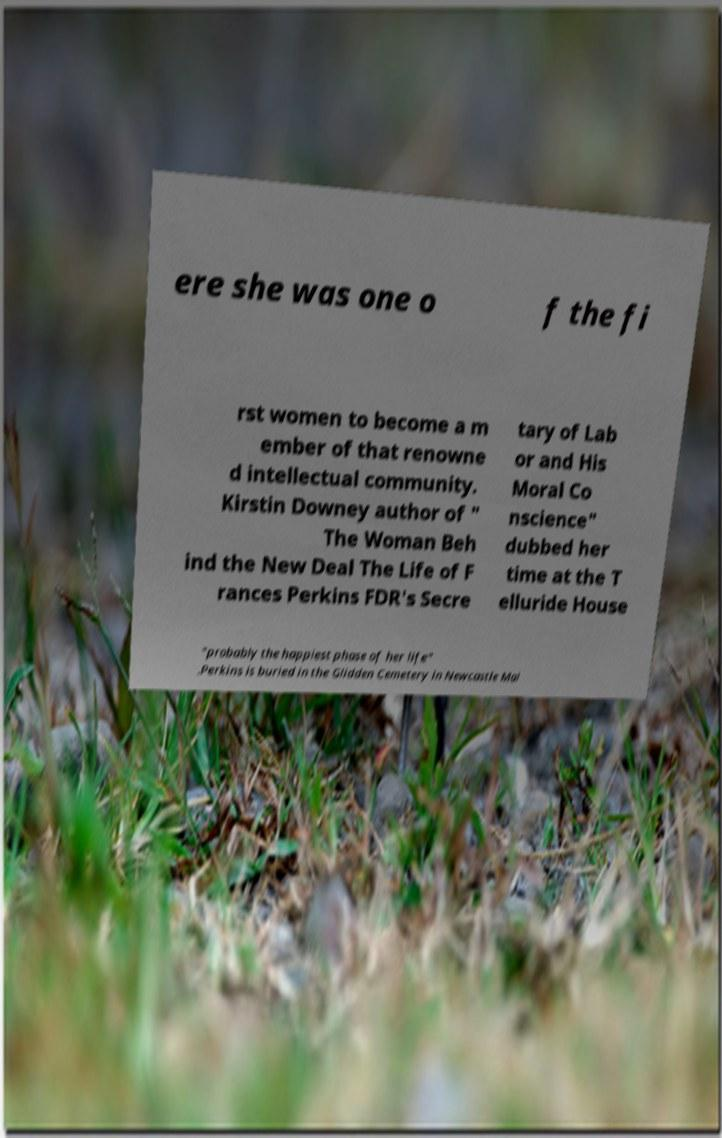There's text embedded in this image that I need extracted. Can you transcribe it verbatim? ere she was one o f the fi rst women to become a m ember of that renowne d intellectual community. Kirstin Downey author of " The Woman Beh ind the New Deal The Life of F rances Perkins FDR's Secre tary of Lab or and His Moral Co nscience" dubbed her time at the T elluride House "probably the happiest phase of her life" .Perkins is buried in the Glidden Cemetery in Newcastle Mai 